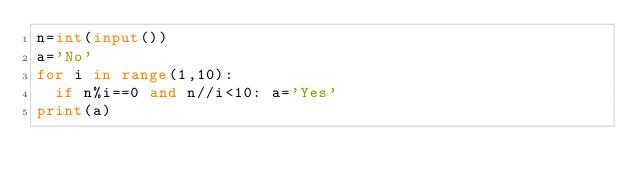<code> <loc_0><loc_0><loc_500><loc_500><_Python_>n=int(input())
a='No'
for i in range(1,10):
  if n%i==0 and n//i<10: a='Yes'
print(a)</code> 